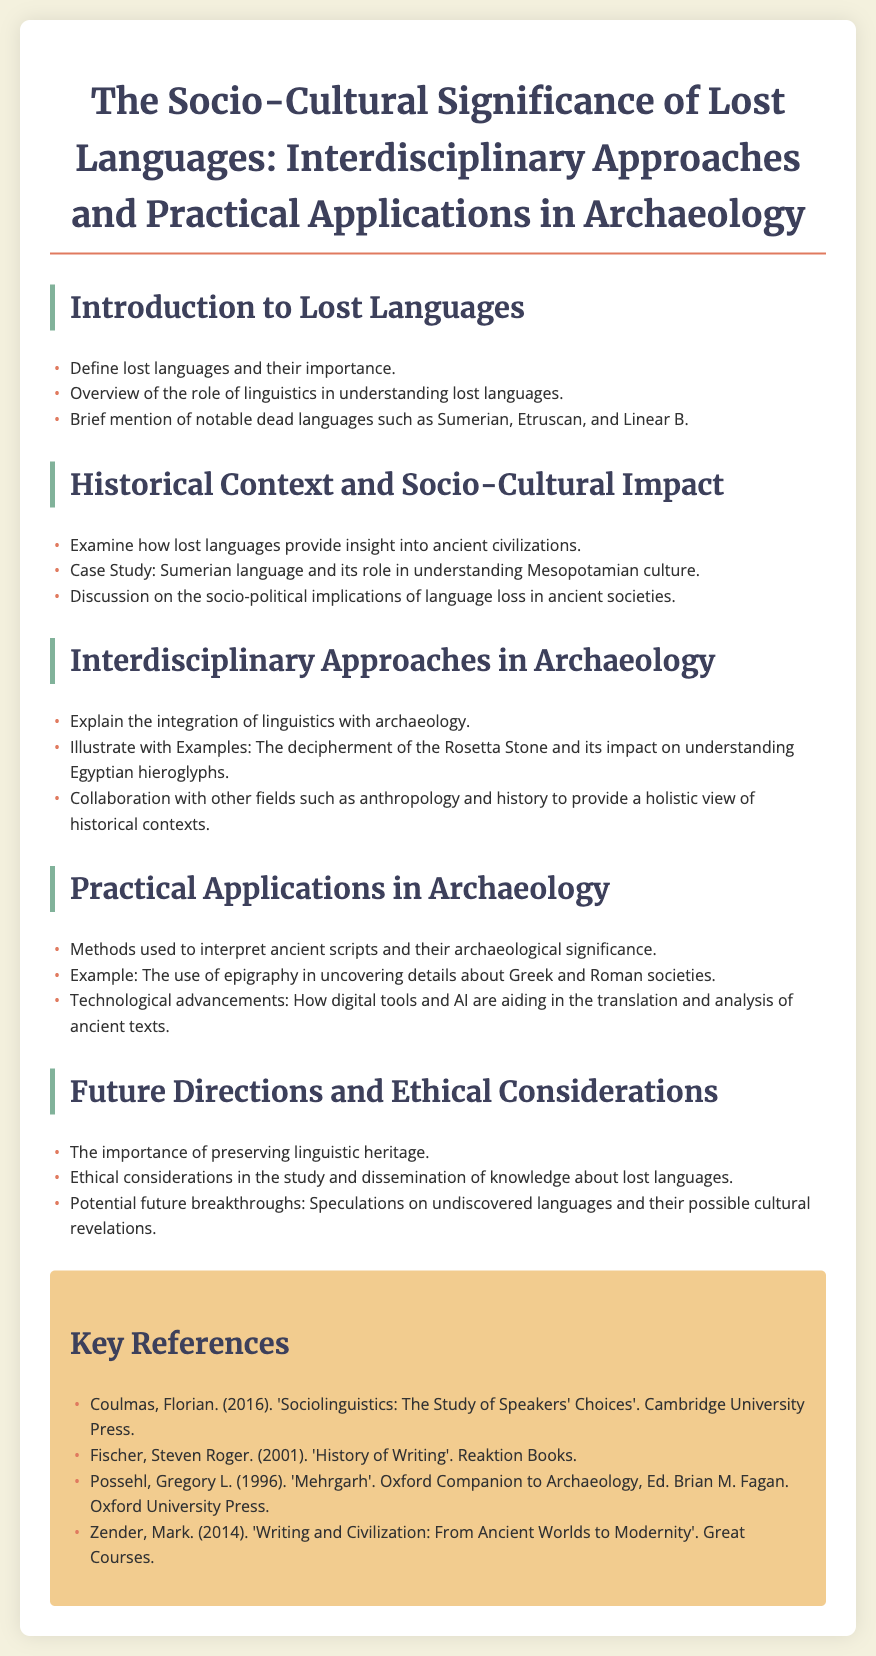What are some notable dead languages mentioned? The document lists notable dead languages such as Sumerian, Etruscan, and Linear B.
Answer: Sumerian, Etruscan, Linear B What is the significance of lost languages in understanding ancient civilizations? The document states that lost languages provide insight into ancient civilizations.
Answer: Insight into ancient civilizations Which ancient language case study is discussed in relation to Mesopotamian culture? The case study highlighted in the document is about the Sumerian language.
Answer: Sumerian What is one of the interdisciplinary approaches used in archaeology? The document explains the integration of linguistics with archaeology as one approach.
Answer: Integration of linguistics with archaeology What technological advancements are aiding in the study of ancient texts? The document mentions that digital tools and AI are aiding in the translation and analysis of ancient texts.
Answer: Digital tools and AI What ethical consideration is highlighted in the study of lost languages? The document points out the importance of preserving linguistic heritage.
Answer: Preserving linguistic heritage How many key references are listed in the document? The document includes a list of four key references.
Answer: Four Which specific example is used in the practical applications section concerning Greek and Roman societies? The example given in the document is the use of epigraphy.
Answer: Use of epigraphy 